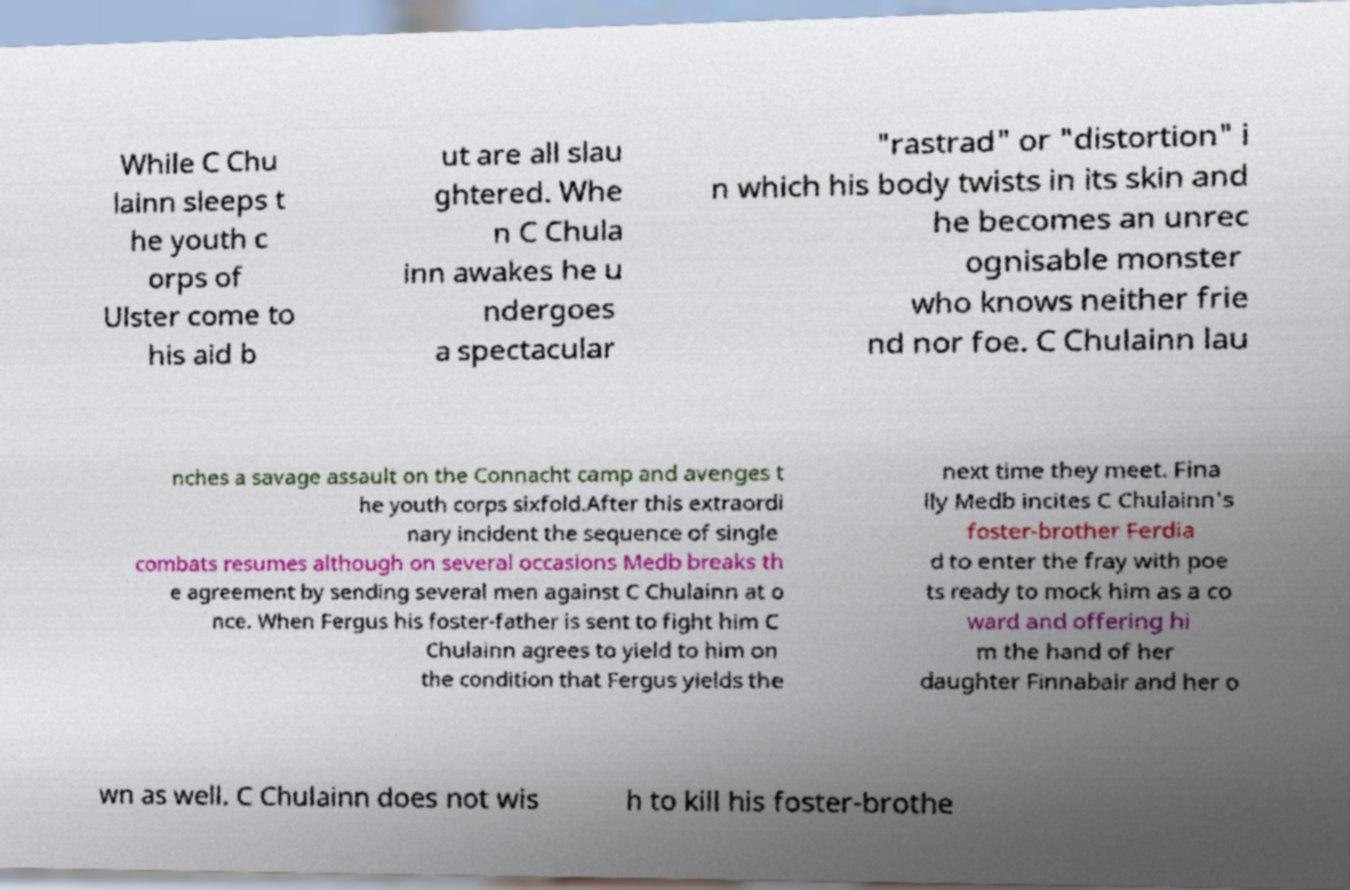Can you read and provide the text displayed in the image?This photo seems to have some interesting text. Can you extract and type it out for me? While C Chu lainn sleeps t he youth c orps of Ulster come to his aid b ut are all slau ghtered. Whe n C Chula inn awakes he u ndergoes a spectacular "rastrad" or "distortion" i n which his body twists in its skin and he becomes an unrec ognisable monster who knows neither frie nd nor foe. C Chulainn lau nches a savage assault on the Connacht camp and avenges t he youth corps sixfold.After this extraordi nary incident the sequence of single combats resumes although on several occasions Medb breaks th e agreement by sending several men against C Chulainn at o nce. When Fergus his foster-father is sent to fight him C Chulainn agrees to yield to him on the condition that Fergus yields the next time they meet. Fina lly Medb incites C Chulainn's foster-brother Ferdia d to enter the fray with poe ts ready to mock him as a co ward and offering hi m the hand of her daughter Finnabair and her o wn as well. C Chulainn does not wis h to kill his foster-brothe 